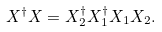Convert formula to latex. <formula><loc_0><loc_0><loc_500><loc_500>X ^ { \dagger } X = X _ { 2 } ^ { \dagger } X _ { 1 } ^ { \dagger } X _ { 1 } X _ { 2 } .</formula> 